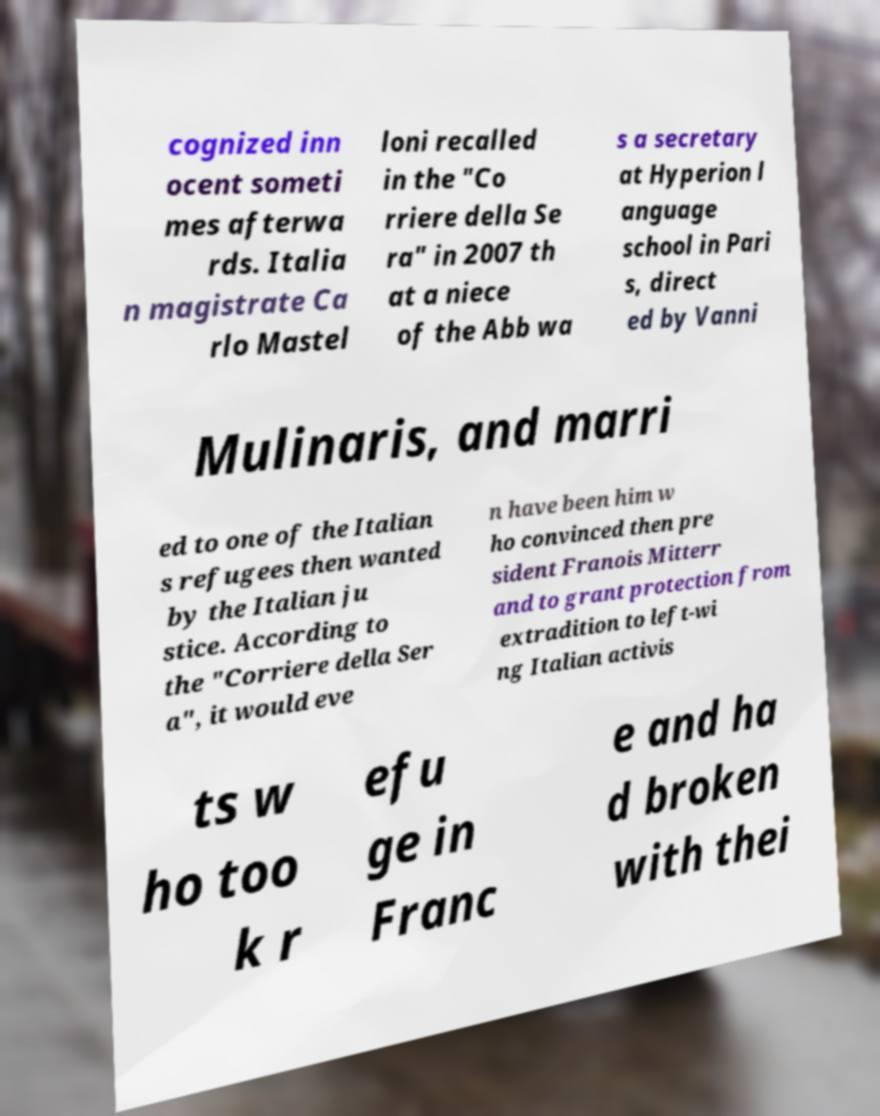Can you read and provide the text displayed in the image?This photo seems to have some interesting text. Can you extract and type it out for me? cognized inn ocent someti mes afterwa rds. Italia n magistrate Ca rlo Mastel loni recalled in the "Co rriere della Se ra" in 2007 th at a niece of the Abb wa s a secretary at Hyperion l anguage school in Pari s, direct ed by Vanni Mulinaris, and marri ed to one of the Italian s refugees then wanted by the Italian ju stice. According to the "Corriere della Ser a", it would eve n have been him w ho convinced then pre sident Franois Mitterr and to grant protection from extradition to left-wi ng Italian activis ts w ho too k r efu ge in Franc e and ha d broken with thei 